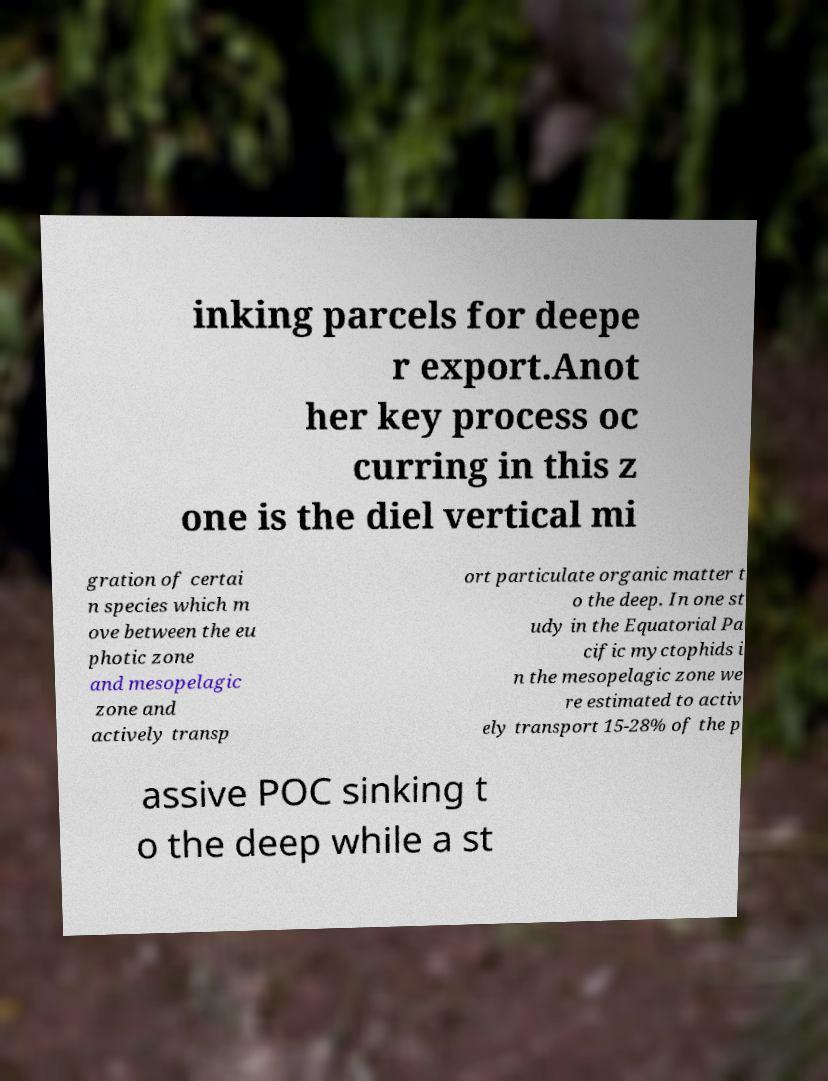Can you read and provide the text displayed in the image?This photo seems to have some interesting text. Can you extract and type it out for me? inking parcels for deepe r export.Anot her key process oc curring in this z one is the diel vertical mi gration of certai n species which m ove between the eu photic zone and mesopelagic zone and actively transp ort particulate organic matter t o the deep. In one st udy in the Equatorial Pa cific myctophids i n the mesopelagic zone we re estimated to activ ely transport 15-28% of the p assive POC sinking t o the deep while a st 